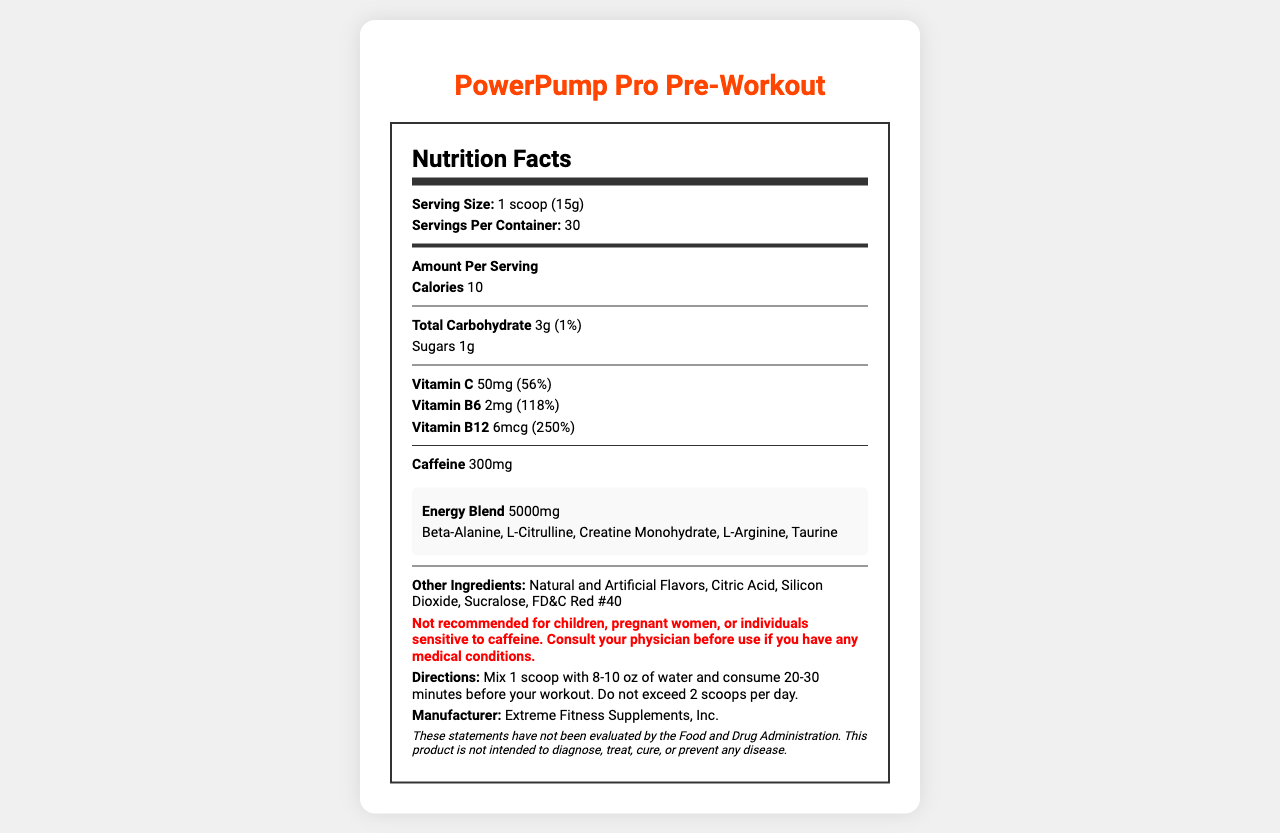what is the serving size of the PowerPump Pro Pre-Workout? The document states that the serving size is 1 scoop (15g) under the "Serving Size" section.
Answer: 1 scoop (15g) how many servings are in one container of the PowerPump Pro Pre-Workout? The "Servings Per Container" section of the document clearly mentions that there are 30 servings per container.
Answer: 30 what is the amount of caffeine per serving in PowerPump Pro Pre-Workout? The "Caffeine" section of the document states that there are 300mg of caffeine per serving.
Answer: 300mg which vitamins are included in the PowerPump Pro Pre-Workout and their amounts? The document lists Vitamin C (50mg), Vitamin B6 (2mg), and Vitamin B12 (6mcg) in the nutrition facts.
Answer: Vitamin C (50mg), Vitamin B6 (2mg), Vitamin B12 (6mcg) how much total carbohydrate is in one serving of PowerPump Pro Pre-Workout? The "Total Carbohydrate" section specifies that there are 3g of total carbohydrates per serving, which is 1% of the daily value.
Answer: 3g (1% DV) what are the instructions for consuming PowerPump Pro Pre-Workout? A. Mix 1 scoop with 8-10 oz of water and consume 20-30 minutes before your workout. Do not exceed 2 scoops per day. B. Mix 2 scoops with 8-10 oz of water and consume 10-20 minutes before your workout. Do not exceed 3 scoops per day. C. Mix 1 scoop with 12-15 oz of water and consume 30-40 minutes before your workout. D. Mix 2 scoops with 12-15 oz of water and consume 15-25 minutes before your workout. The "Directions" section of the document states to mix 1 scoop with 8-10 oz of water and consume 20-30 minutes before your workout, and not to exceed 2 scoops per day.
Answer: A which ingredient in the PowerPump Pro Pre-Workout is not part of the energy blend? A. Beta-Alanine B. L-Citrulline C. Creatine Monohydrate D. FD&C Red #40 FD&C Red #40 is listed under "Other Ingredients," whereas the others are part of the "Energy Blend."
Answer: D is the PowerPump Pro Pre-Workout recommended for children? The "Warning" section explicitly states that it is not recommended for children.
Answer: No summarize the main features of the PowerPump Pro Pre-Workout. The document provides detailed nutrition facts, ingredients, serving instructions, and warnings for the PowerPump Pro Pre-Workout, highlighting its energy-boosting components.
Answer: The PowerPump Pro Pre-Workout is a supplement designed to enhance workout performance. It contains key energy-boosting ingredients such as Beta-Alanine, L-Citrulline, and 300mg of caffeine per serving. Each serving provides essential vitamins including Vitamin C, Vitamin B6, and Vitamin B12. The supplement has a low calorie count and is not recommended for certain groups like children or pregnant women. what is the sugar content per serving in the PowerPump Pro Pre-Workout? The Nutrition Facts label lists the sugar content as 1g per serving under the "Sugars" section.
Answer: 1g which company manufactures the PowerPump Pro Pre-Workout? The manufacturer information at the bottom of the document states that the product is made by Extreme Fitness Supplements, Inc.
Answer: Extreme Fitness Supplements, Inc. how many calories are there in one serving of PowerPump Pro Pre-Workout? The "Calories" section clearly mentions that there are 10 calories per serving.
Answer: 10 aside from energy-boosting ingredients, what flavors and additives are included in the PowerPump Pro Pre-Workout? The "Other Ingredients" section lists these as additional flavors and additives in the product.
Answer: Natural and Artificial Flavors, Citric Acid, Silicon Dioxide, Sucralose, FD&C Red #40 what is the total amount of energy blend in one serving of PowerPump Pro Pre-Workout, and what does it consist of? The document states that each serving contains an energy blend of 5000mg consisting of Beta-Alanine, L-Citrulline, Creatine Monohydrate, L-Arginine, and Taurine.
Answer: 5000mg; Beta-Alanine, L-Citrulline, Creatine Monohydrate, L-Arginine, Taurine what is the daily value percentage of Vitamin B12 in one serving? The document lists that each serving contains 250% of the daily value of Vitamin B12.
Answer: 250% how much silicon dioxide is in the PowerPump Pro Pre-Workout? The document mentions silicon dioxide as one of the other ingredients but does not specify the amount.
Answer: Cannot be determined is there any warning or disclaimer related to the use of the PowerPump Pro Pre-Workout? The document includes a warning stating it is not recommended for children, pregnant women, or individuals sensitive to caffeine, and advises consulting a physician before use for those with medical conditions, along with a disclaimer that the statements have not been evaluated by the FDA.
Answer: Yes does the PowerPump Pro Pre-Workout claim to diagnose, treat, cure, or prevent any disease? The disclaimer at the bottom of the document explicitly states that the product is not intended to diagnose, treat, cure, or prevent any disease.
Answer: No 